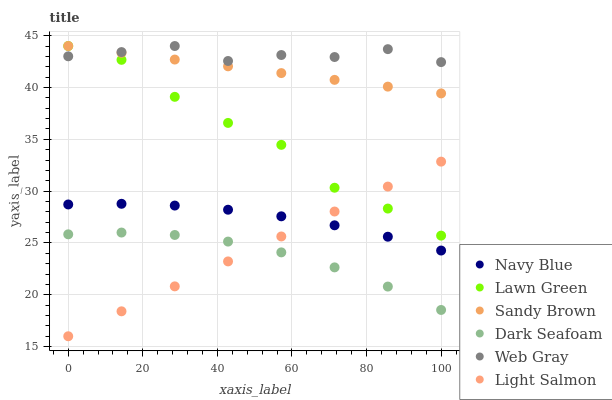Does Dark Seafoam have the minimum area under the curve?
Answer yes or no. Yes. Does Web Gray have the maximum area under the curve?
Answer yes or no. Yes. Does Light Salmon have the minimum area under the curve?
Answer yes or no. No. Does Light Salmon have the maximum area under the curve?
Answer yes or no. No. Is Sandy Brown the smoothest?
Answer yes or no. Yes. Is Lawn Green the roughest?
Answer yes or no. Yes. Is Light Salmon the smoothest?
Answer yes or no. No. Is Light Salmon the roughest?
Answer yes or no. No. Does Light Salmon have the lowest value?
Answer yes or no. Yes. Does Web Gray have the lowest value?
Answer yes or no. No. Does Sandy Brown have the highest value?
Answer yes or no. Yes. Does Light Salmon have the highest value?
Answer yes or no. No. Is Light Salmon less than Web Gray?
Answer yes or no. Yes. Is Navy Blue greater than Dark Seafoam?
Answer yes or no. Yes. Does Sandy Brown intersect Web Gray?
Answer yes or no. Yes. Is Sandy Brown less than Web Gray?
Answer yes or no. No. Is Sandy Brown greater than Web Gray?
Answer yes or no. No. Does Light Salmon intersect Web Gray?
Answer yes or no. No. 